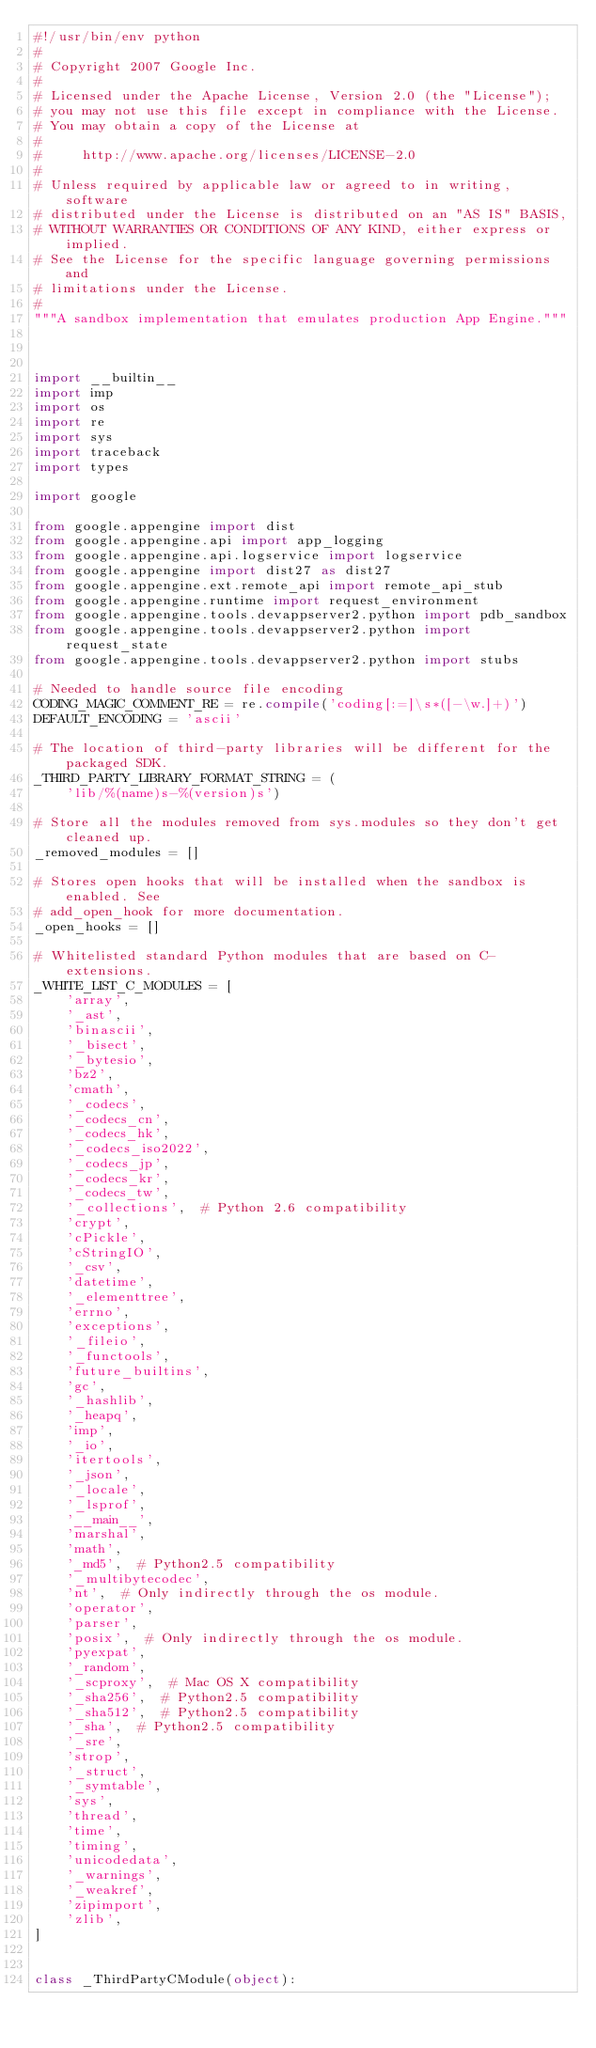<code> <loc_0><loc_0><loc_500><loc_500><_Python_>#!/usr/bin/env python
#
# Copyright 2007 Google Inc.
#
# Licensed under the Apache License, Version 2.0 (the "License");
# you may not use this file except in compliance with the License.
# You may obtain a copy of the License at
#
#     http://www.apache.org/licenses/LICENSE-2.0
#
# Unless required by applicable law or agreed to in writing, software
# distributed under the License is distributed on an "AS IS" BASIS,
# WITHOUT WARRANTIES OR CONDITIONS OF ANY KIND, either express or implied.
# See the License for the specific language governing permissions and
# limitations under the License.
#
"""A sandbox implementation that emulates production App Engine."""



import __builtin__
import imp
import os
import re
import sys
import traceback
import types

import google

from google.appengine import dist
from google.appengine.api import app_logging
from google.appengine.api.logservice import logservice
from google.appengine import dist27 as dist27
from google.appengine.ext.remote_api import remote_api_stub
from google.appengine.runtime import request_environment
from google.appengine.tools.devappserver2.python import pdb_sandbox
from google.appengine.tools.devappserver2.python import request_state
from google.appengine.tools.devappserver2.python import stubs

# Needed to handle source file encoding
CODING_MAGIC_COMMENT_RE = re.compile('coding[:=]\s*([-\w.]+)')
DEFAULT_ENCODING = 'ascii'

# The location of third-party libraries will be different for the packaged SDK.
_THIRD_PARTY_LIBRARY_FORMAT_STRING = (
    'lib/%(name)s-%(version)s')

# Store all the modules removed from sys.modules so they don't get cleaned up.
_removed_modules = []

# Stores open hooks that will be installed when the sandbox is enabled. See
# add_open_hook for more documentation.
_open_hooks = []

# Whitelisted standard Python modules that are based on C-extensions.
_WHITE_LIST_C_MODULES = [
    'array',
    '_ast',
    'binascii',
    '_bisect',
    '_bytesio',
    'bz2',
    'cmath',
    '_codecs',
    '_codecs_cn',
    '_codecs_hk',
    '_codecs_iso2022',
    '_codecs_jp',
    '_codecs_kr',
    '_codecs_tw',
    '_collections',  # Python 2.6 compatibility
    'crypt',
    'cPickle',
    'cStringIO',
    '_csv',
    'datetime',
    '_elementtree',
    'errno',
    'exceptions',
    '_fileio',
    '_functools',
    'future_builtins',
    'gc',
    '_hashlib',
    '_heapq',
    'imp',
    '_io',
    'itertools',
    '_json',
    '_locale',
    '_lsprof',
    '__main__',
    'marshal',
    'math',
    '_md5',  # Python2.5 compatibility
    '_multibytecodec',
    'nt',  # Only indirectly through the os module.
    'operator',
    'parser',
    'posix',  # Only indirectly through the os module.
    'pyexpat',
    '_random',
    '_scproxy',  # Mac OS X compatibility
    '_sha256',  # Python2.5 compatibility
    '_sha512',  # Python2.5 compatibility
    '_sha',  # Python2.5 compatibility
    '_sre',
    'strop',
    '_struct',
    '_symtable',
    'sys',
    'thread',
    'time',
    'timing',
    'unicodedata',
    '_warnings',
    '_weakref',
    'zipimport',
    'zlib',
]


class _ThirdPartyCModule(object):</code> 